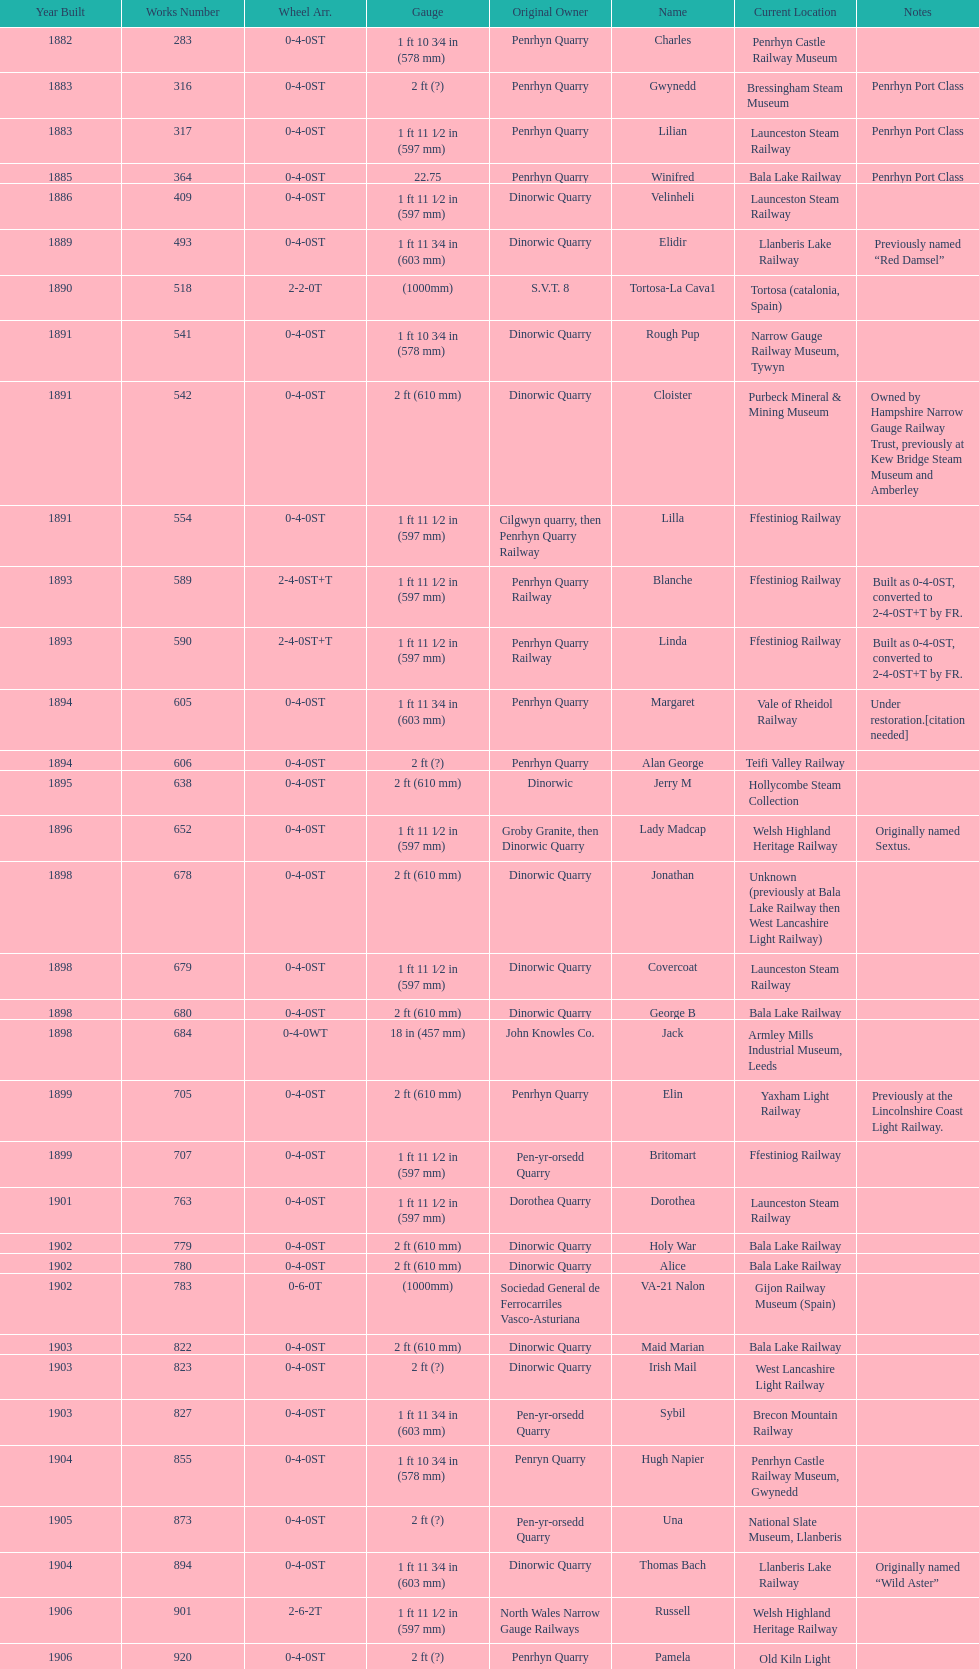Which original owner had the most locomotives? Penrhyn Quarry. 